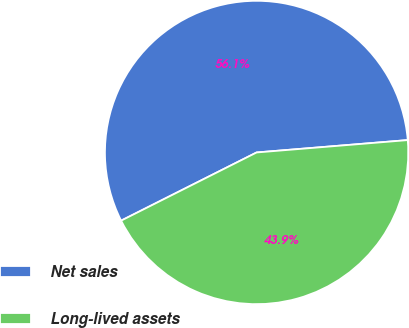Convert chart. <chart><loc_0><loc_0><loc_500><loc_500><pie_chart><fcel>Net sales<fcel>Long-lived assets<nl><fcel>56.12%<fcel>43.88%<nl></chart> 